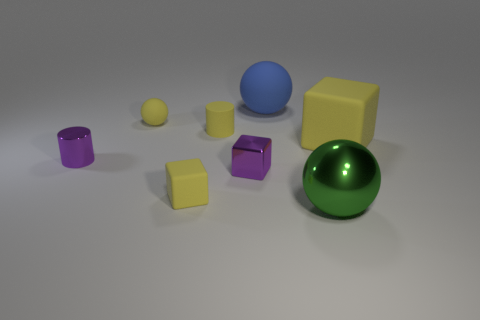Does the tiny yellow object that is in front of the purple shiny cylinder have the same shape as the green shiny object?
Offer a terse response. No. How many brown metal cubes have the same size as the purple block?
Ensure brevity in your answer.  0. The big rubber object that is the same color as the tiny rubber ball is what shape?
Provide a succinct answer. Cube. Are there any small yellow rubber balls behind the matte block that is on the right side of the green shiny sphere?
Provide a short and direct response. Yes. How many things are either small yellow matte objects that are in front of the big block or big shiny cylinders?
Make the answer very short. 1. What number of large cyan metal cylinders are there?
Your answer should be compact. 0. There is another big thing that is made of the same material as the large blue object; what is its shape?
Your answer should be compact. Cube. What is the size of the matte block that is to the left of the shiny thing that is on the right side of the big blue sphere?
Provide a succinct answer. Small. What number of objects are either tiny metallic things that are to the right of the tiny yellow sphere or tiny things that are in front of the yellow cylinder?
Provide a succinct answer. 3. Are there fewer big green things than tiny blocks?
Your answer should be compact. Yes. 